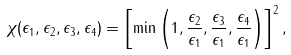<formula> <loc_0><loc_0><loc_500><loc_500>\chi ( \epsilon _ { 1 } , \epsilon _ { 2 } , \epsilon _ { 3 } , \epsilon _ { 4 } ) = \left [ \min \left ( 1 , \frac { \epsilon _ { 2 } } { \epsilon _ { 1 } } , \frac { \epsilon _ { 3 } } { \epsilon _ { 1 } } , \frac { \epsilon _ { 4 } } { \epsilon _ { 1 } } \right ) \right ] ^ { 2 } ,</formula> 